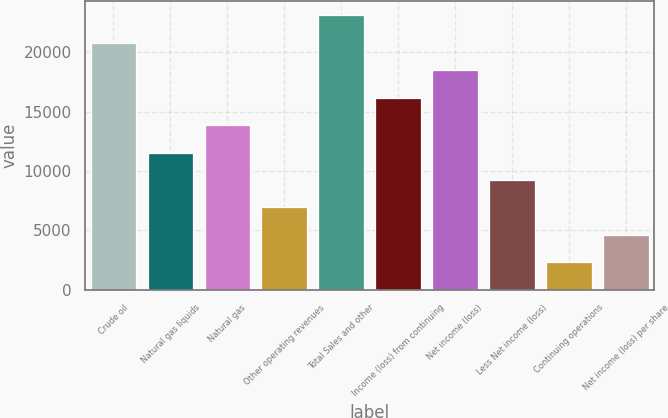Convert chart. <chart><loc_0><loc_0><loc_500><loc_500><bar_chart><fcel>Crude oil<fcel>Natural gas liquids<fcel>Natural gas<fcel>Other operating revenues<fcel>Total Sales and other<fcel>Income (loss) from continuing<fcel>Net income (loss)<fcel>Less Net income (loss)<fcel>Continuing operations<fcel>Net income (loss) per share<nl><fcel>20800.9<fcel>11556.5<fcel>13867.6<fcel>6934.3<fcel>23112<fcel>16178.7<fcel>18489.8<fcel>9245.4<fcel>2312.1<fcel>4623.2<nl></chart> 